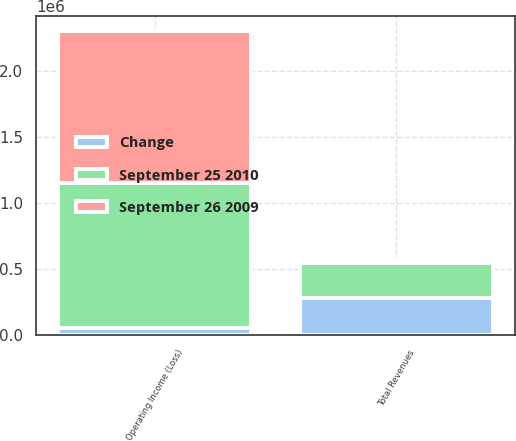Convert chart to OTSL. <chart><loc_0><loc_0><loc_500><loc_500><stacked_bar_chart><ecel><fcel>Total Revenues<fcel>Operating Income (Loss)<nl><fcel>Change<fcel>283142<fcel>53071<nl><fcel>September 25 2010<fcel>264900<fcel>1.09768e+06<nl><fcel>September 26 2009<fcel>18242<fcel>1.15076e+06<nl></chart> 